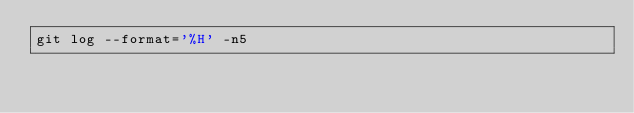<code> <loc_0><loc_0><loc_500><loc_500><_Bash_>git log --format='%H' -n5
</code> 